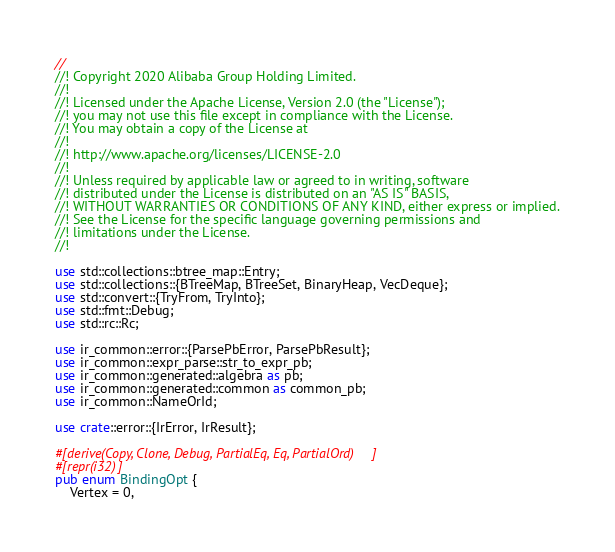<code> <loc_0><loc_0><loc_500><loc_500><_Rust_>//
//! Copyright 2020 Alibaba Group Holding Limited.
//!
//! Licensed under the Apache License, Version 2.0 (the "License");
//! you may not use this file except in compliance with the License.
//! You may obtain a copy of the License at
//!
//! http://www.apache.org/licenses/LICENSE-2.0
//!
//! Unless required by applicable law or agreed to in writing, software
//! distributed under the License is distributed on an "AS IS" BASIS,
//! WITHOUT WARRANTIES OR CONDITIONS OF ANY KIND, either express or implied.
//! See the License for the specific language governing permissions and
//! limitations under the License.
//!

use std::collections::btree_map::Entry;
use std::collections::{BTreeMap, BTreeSet, BinaryHeap, VecDeque};
use std::convert::{TryFrom, TryInto};
use std::fmt::Debug;
use std::rc::Rc;

use ir_common::error::{ParsePbError, ParsePbResult};
use ir_common::expr_parse::str_to_expr_pb;
use ir_common::generated::algebra as pb;
use ir_common::generated::common as common_pb;
use ir_common::NameOrId;

use crate::error::{IrError, IrResult};

#[derive(Copy, Clone, Debug, PartialEq, Eq, PartialOrd)]
#[repr(i32)]
pub enum BindingOpt {
    Vertex = 0,</code> 